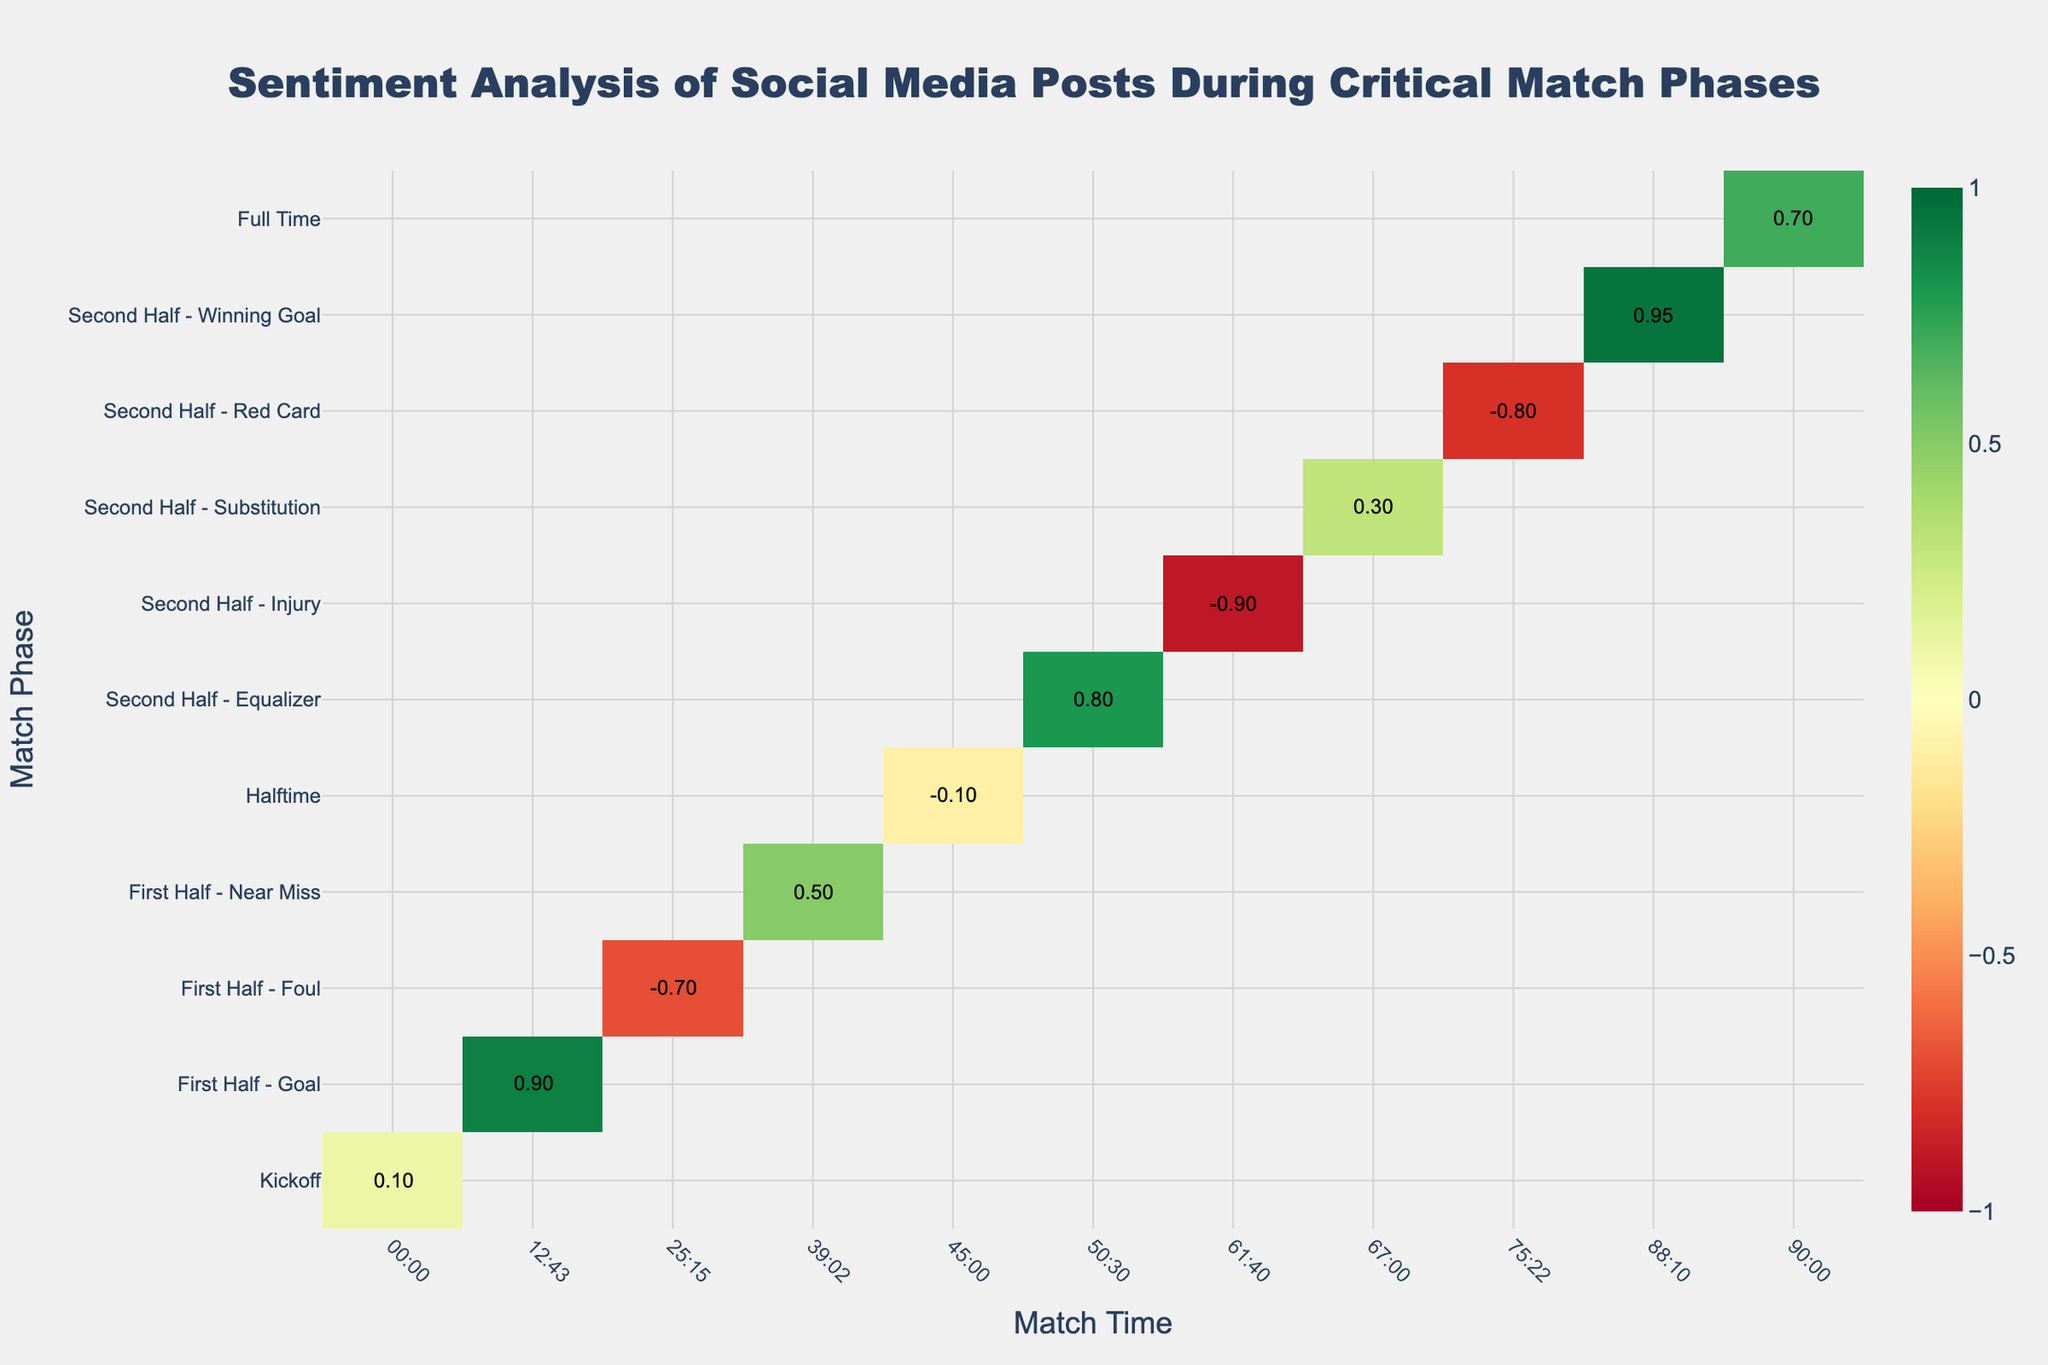How does the sentiment score change between the kickoff and halftime? Look at the sentiment score at the kickoff (00:00) which is 0.1 and compare it with the score at halftime (45:00) which is -0.1. The score changes by (0.1 - (-0.1)) = 0.2.
Answer: The sentiment score changes by 0.2 Which match phase had the lowest sentiment score and what was the value? Observe the sentiment scores for all match phases and find the lowest one, which is during the "Second Half - Injury" at 61:40 with a score of -0.9.
Answer: Second Half - Injury, -0.9 Compare the sentiment scores between the two goals in the first and second halves. Which goal had a higher sentiment score? The first goal (First Half - Goal at 12:43) has a sentiment score of 0.9, and the second goal (Second Half - Winning Goal at 88:10) has a score of 0.95. Compare these two scores to see the second goal has a higher score.
Answer: The second goal had a higher sentiment score of 0.95 What is the average sentiment score of all match phases? Add up all the sentiment scores (0.1 + 0.9 + -0.7 + 0.5 + -0.1 + 0.8 + -0.9 + 0.3 + -0.8 + 0.95 + 0.7) = 1.75 and divide by the number of phases (11). The average sentiment score is 1.75/11.
Answer: 0.159 Which match phase has the highest positive sentiment score? Look at all positive sentiment scores and determine the highest one, which is during the "Second Half - Winning Goal" at 88:10 with a score of 0.95.
Answer: Second Half - Winning Goal During what match phase does the sentiment score first drop below zero? Identify the first mention of a negative sentiment score in chronological order, which occurs at "First Half - Foul" at 25:15 with a score of -0.7.
Answer: First Half - Foul What is the total range of sentiment scores seen during the match? Find the maximum and minimum sentiment scores (0.95 and -0.9, respectively) and calculate the range by subtracting the minimum from the maximum (0.95 - (-0.9)).
Answer: 1.85 Compare the sentiment score at the time of the equalizer and the immediate next event. How do they differ? Sentiment score at "Second Half - Equalizer" (50:30) is 0.8, while the immediate next event, "Second Half - Injury" (61:40), has a score of -0.9. The difference is 0.8 - (-0.9).
Answer: The scores differ by 1.7 How long after kickoff was the highest sentiment score recorded? The highest sentiment score occurs during the "Second Half - Winning Goal" at 88:10. Calculate the time elapsed from the kickoff (00:00) which is 88 minutes and 10 seconds.
Answer: 88 minutes and 10 seconds What color does the heatmap show for the event with the sentiment score of -0.8, and what does it represent? Identify the color associated with the sentiment score of -0.8 at "Second Half - Red Card" and look for a corresponding visual representation in the heatmap's color scale (likely a shade of red as negative scores use red hues).
Answer: Red, representing a highly negative sentiment 